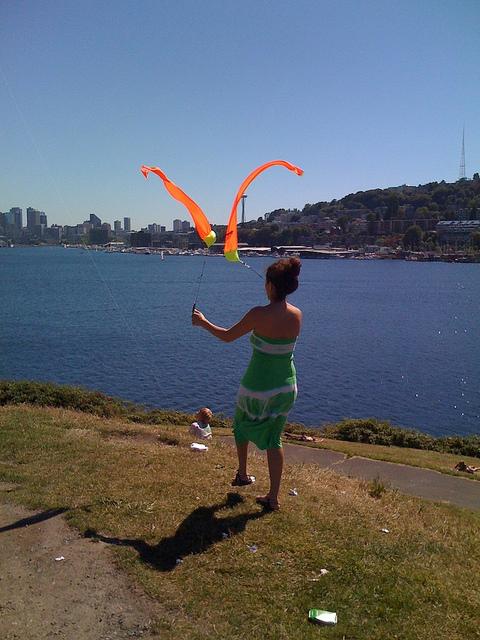Is the woman doing a dance with the kite?
Keep it brief. No. What is this woman holding?
Be succinct. Kite. Why is the boy looking up?
Short answer required. Kite. 